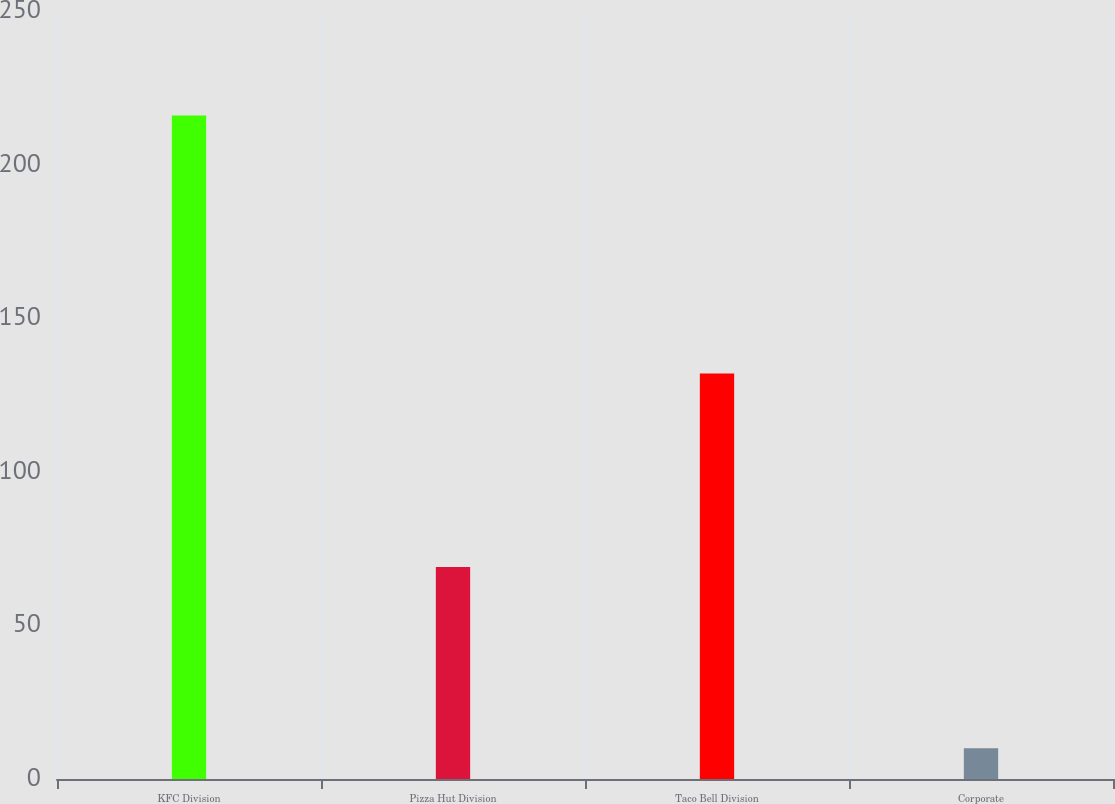Convert chart to OTSL. <chart><loc_0><loc_0><loc_500><loc_500><bar_chart><fcel>KFC Division<fcel>Pizza Hut Division<fcel>Taco Bell Division<fcel>Corporate<nl><fcel>216<fcel>69<fcel>132<fcel>10<nl></chart> 